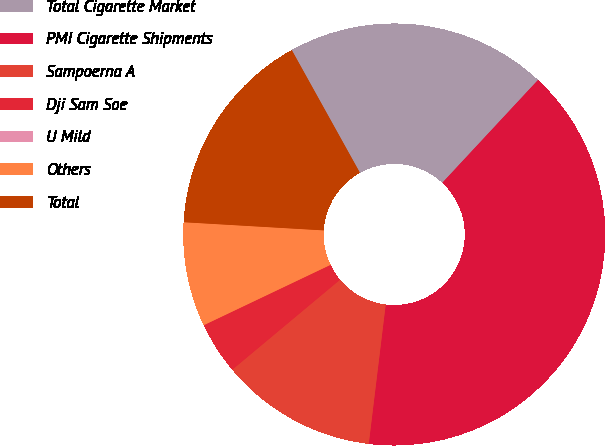<chart> <loc_0><loc_0><loc_500><loc_500><pie_chart><fcel>Total Cigarette Market<fcel>PMI Cigarette Shipments<fcel>Sampoerna A<fcel>Dji Sam Soe<fcel>U Mild<fcel>Others<fcel>Total<nl><fcel>20.0%<fcel>40.0%<fcel>12.0%<fcel>4.0%<fcel>0.0%<fcel>8.0%<fcel>16.0%<nl></chart> 